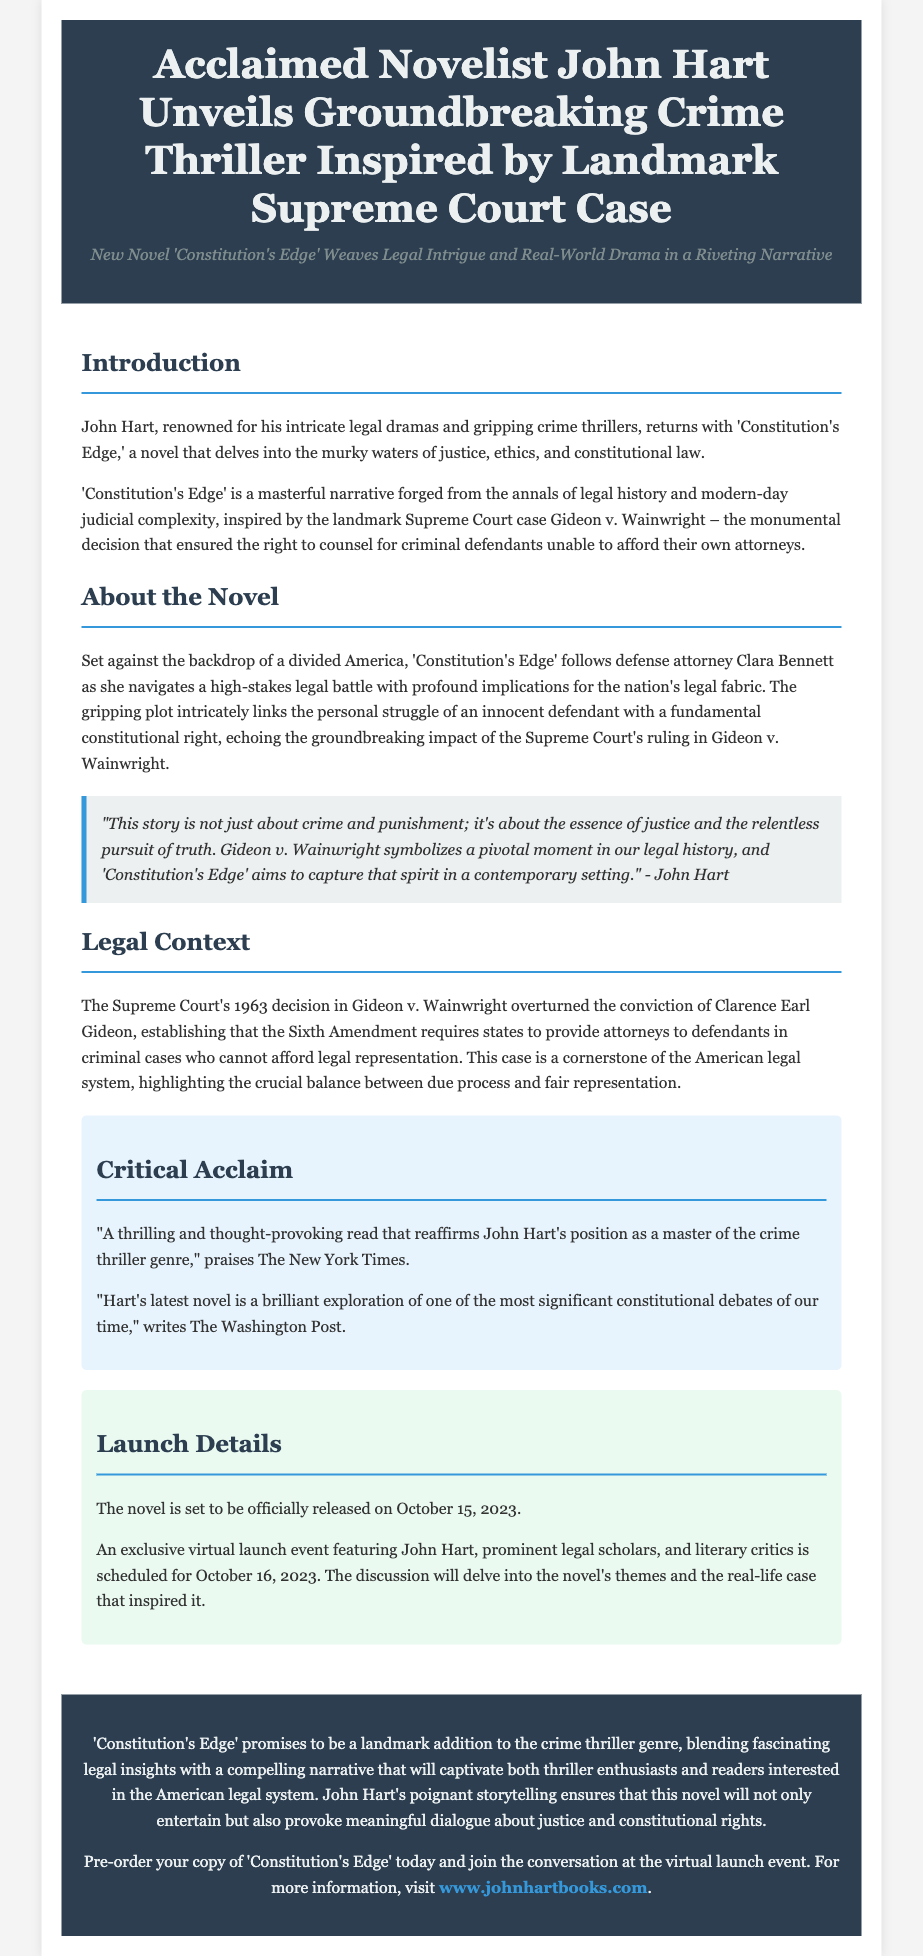What is the title of the new novel? The title of the new novel is 'Constitution's Edge'.
Answer: 'Constitution's Edge' Who is the author of the novel? The author of the novel is John Hart.
Answer: John Hart What landmark Supreme Court case inspired the novel? The novel is inspired by Gideon v. Wainwright.
Answer: Gideon v. Wainwright When is the official release date of the novel? The official release date of the novel is October 15, 2023.
Answer: October 15, 2023 What is the main character's profession in the novel? The main character, Clara Bennett, is a defense attorney.
Answer: Defense attorney What is the central theme of 'Constitution's Edge'? The central theme revolves around justice, ethics, and constitutional law.
Answer: Justice, ethics, and constitutional law What type of event is scheduled for October 16, 2023? An exclusive virtual launch event is scheduled for this date.
Answer: Exclusive virtual launch event Which publication praised the novel as a thrilling and thought-provoking read? The New York Times praised the novel.
Answer: The New York Times What is the website for more information about the novel? The website for more information is www.johnhartbooks.com.
Answer: www.johnhartbooks.com 